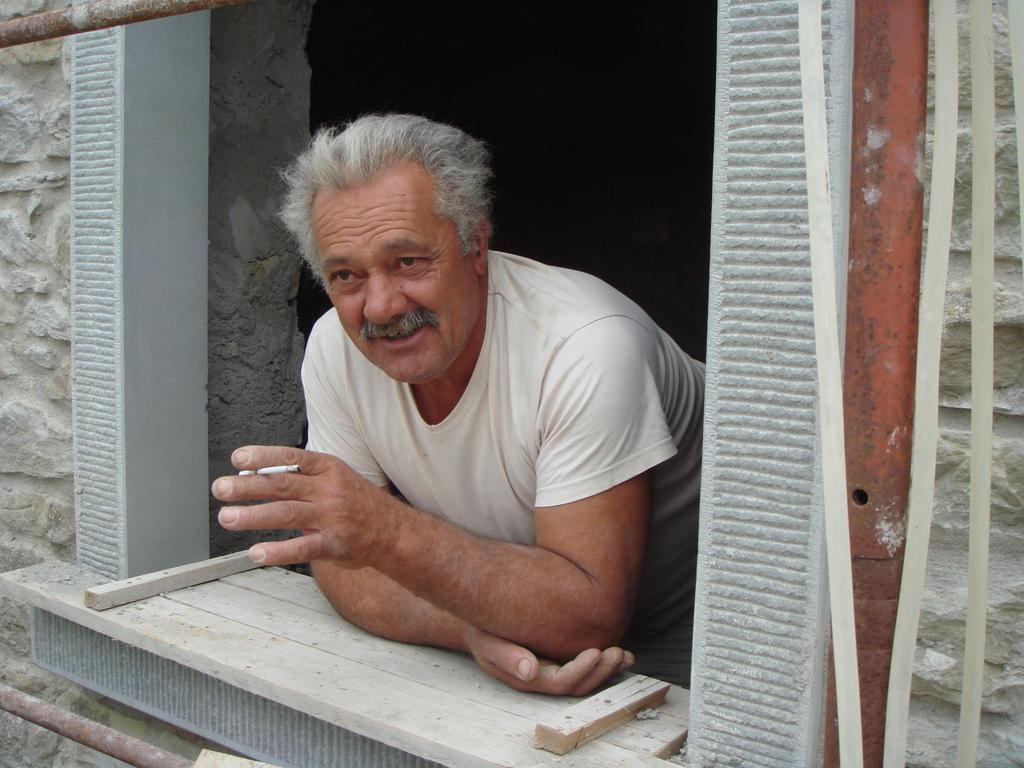How would you summarize this image in a sentence or two? In this picture we can see a man wearing a t-shirt, he is holding an object in between his two fingers and it seems like a cigarette. He kept his hands on a wooden plank. on the right and left side of the picture we can see the wall. At the top and bottom portion of the picture we can see iron rods. 